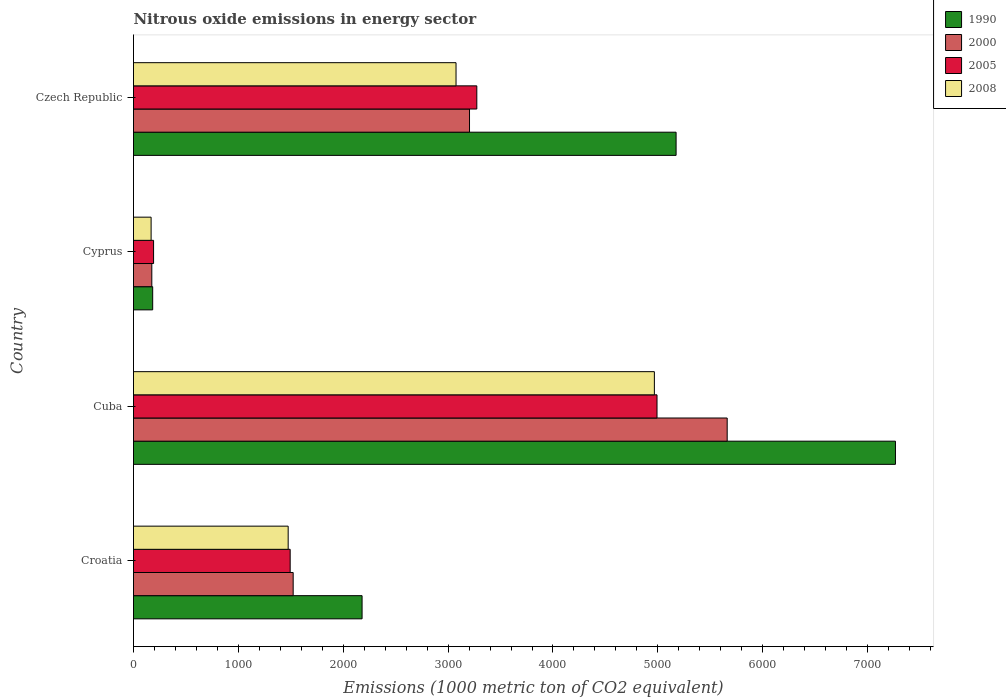How many different coloured bars are there?
Provide a short and direct response. 4. How many bars are there on the 1st tick from the top?
Your answer should be very brief. 4. How many bars are there on the 3rd tick from the bottom?
Provide a short and direct response. 4. What is the label of the 1st group of bars from the top?
Offer a very short reply. Czech Republic. What is the amount of nitrous oxide emitted in 2005 in Croatia?
Provide a short and direct response. 1494. Across all countries, what is the maximum amount of nitrous oxide emitted in 2008?
Ensure brevity in your answer.  4967. Across all countries, what is the minimum amount of nitrous oxide emitted in 2005?
Provide a short and direct response. 191.4. In which country was the amount of nitrous oxide emitted in 2005 maximum?
Offer a very short reply. Cuba. In which country was the amount of nitrous oxide emitted in 2008 minimum?
Keep it short and to the point. Cyprus. What is the total amount of nitrous oxide emitted in 2008 in the graph?
Give a very brief answer. 9685.3. What is the difference between the amount of nitrous oxide emitted in 2008 in Cuba and that in Cyprus?
Your answer should be compact. 4799.1. What is the difference between the amount of nitrous oxide emitted in 2005 in Czech Republic and the amount of nitrous oxide emitted in 2008 in Cuba?
Your answer should be very brief. -1693.3. What is the average amount of nitrous oxide emitted in 1990 per country?
Your response must be concise. 3700.65. What is the difference between the amount of nitrous oxide emitted in 2005 and amount of nitrous oxide emitted in 2000 in Czech Republic?
Your response must be concise. 69.6. In how many countries, is the amount of nitrous oxide emitted in 1990 greater than 1600 1000 metric ton?
Make the answer very short. 3. What is the ratio of the amount of nitrous oxide emitted in 2005 in Croatia to that in Czech Republic?
Provide a succinct answer. 0.46. What is the difference between the highest and the second highest amount of nitrous oxide emitted in 2008?
Provide a short and direct response. 1891.4. What is the difference between the highest and the lowest amount of nitrous oxide emitted in 1990?
Give a very brief answer. 7083. Is the sum of the amount of nitrous oxide emitted in 2008 in Cuba and Cyprus greater than the maximum amount of nitrous oxide emitted in 1990 across all countries?
Your answer should be compact. No. What does the 1st bar from the bottom in Croatia represents?
Your answer should be very brief. 1990. How many countries are there in the graph?
Ensure brevity in your answer.  4. What is the difference between two consecutive major ticks on the X-axis?
Provide a short and direct response. 1000. Are the values on the major ticks of X-axis written in scientific E-notation?
Offer a terse response. No. Does the graph contain grids?
Provide a short and direct response. No. Where does the legend appear in the graph?
Keep it short and to the point. Top right. How are the legend labels stacked?
Your answer should be very brief. Vertical. What is the title of the graph?
Make the answer very short. Nitrous oxide emissions in energy sector. What is the label or title of the X-axis?
Make the answer very short. Emissions (1000 metric ton of CO2 equivalent). What is the label or title of the Y-axis?
Ensure brevity in your answer.  Country. What is the Emissions (1000 metric ton of CO2 equivalent) of 1990 in Croatia?
Your response must be concise. 2179.7. What is the Emissions (1000 metric ton of CO2 equivalent) in 2000 in Croatia?
Give a very brief answer. 1522.5. What is the Emissions (1000 metric ton of CO2 equivalent) of 2005 in Croatia?
Offer a terse response. 1494. What is the Emissions (1000 metric ton of CO2 equivalent) in 2008 in Croatia?
Your response must be concise. 1474.8. What is the Emissions (1000 metric ton of CO2 equivalent) of 1990 in Cuba?
Your answer should be very brief. 7265.9. What is the Emissions (1000 metric ton of CO2 equivalent) in 2000 in Cuba?
Provide a short and direct response. 5661.3. What is the Emissions (1000 metric ton of CO2 equivalent) of 2005 in Cuba?
Your response must be concise. 4992.1. What is the Emissions (1000 metric ton of CO2 equivalent) of 2008 in Cuba?
Offer a very short reply. 4967. What is the Emissions (1000 metric ton of CO2 equivalent) in 1990 in Cyprus?
Keep it short and to the point. 182.9. What is the Emissions (1000 metric ton of CO2 equivalent) in 2000 in Cyprus?
Your answer should be very brief. 174.6. What is the Emissions (1000 metric ton of CO2 equivalent) of 2005 in Cyprus?
Ensure brevity in your answer.  191.4. What is the Emissions (1000 metric ton of CO2 equivalent) of 2008 in Cyprus?
Provide a short and direct response. 167.9. What is the Emissions (1000 metric ton of CO2 equivalent) in 1990 in Czech Republic?
Keep it short and to the point. 5174.1. What is the Emissions (1000 metric ton of CO2 equivalent) in 2000 in Czech Republic?
Keep it short and to the point. 3204.1. What is the Emissions (1000 metric ton of CO2 equivalent) in 2005 in Czech Republic?
Provide a succinct answer. 3273.7. What is the Emissions (1000 metric ton of CO2 equivalent) in 2008 in Czech Republic?
Offer a very short reply. 3075.6. Across all countries, what is the maximum Emissions (1000 metric ton of CO2 equivalent) in 1990?
Your answer should be very brief. 7265.9. Across all countries, what is the maximum Emissions (1000 metric ton of CO2 equivalent) in 2000?
Your response must be concise. 5661.3. Across all countries, what is the maximum Emissions (1000 metric ton of CO2 equivalent) of 2005?
Keep it short and to the point. 4992.1. Across all countries, what is the maximum Emissions (1000 metric ton of CO2 equivalent) in 2008?
Provide a succinct answer. 4967. Across all countries, what is the minimum Emissions (1000 metric ton of CO2 equivalent) in 1990?
Give a very brief answer. 182.9. Across all countries, what is the minimum Emissions (1000 metric ton of CO2 equivalent) in 2000?
Provide a succinct answer. 174.6. Across all countries, what is the minimum Emissions (1000 metric ton of CO2 equivalent) in 2005?
Ensure brevity in your answer.  191.4. Across all countries, what is the minimum Emissions (1000 metric ton of CO2 equivalent) in 2008?
Keep it short and to the point. 167.9. What is the total Emissions (1000 metric ton of CO2 equivalent) in 1990 in the graph?
Offer a terse response. 1.48e+04. What is the total Emissions (1000 metric ton of CO2 equivalent) of 2000 in the graph?
Ensure brevity in your answer.  1.06e+04. What is the total Emissions (1000 metric ton of CO2 equivalent) in 2005 in the graph?
Make the answer very short. 9951.2. What is the total Emissions (1000 metric ton of CO2 equivalent) of 2008 in the graph?
Provide a short and direct response. 9685.3. What is the difference between the Emissions (1000 metric ton of CO2 equivalent) in 1990 in Croatia and that in Cuba?
Keep it short and to the point. -5086.2. What is the difference between the Emissions (1000 metric ton of CO2 equivalent) of 2000 in Croatia and that in Cuba?
Keep it short and to the point. -4138.8. What is the difference between the Emissions (1000 metric ton of CO2 equivalent) in 2005 in Croatia and that in Cuba?
Ensure brevity in your answer.  -3498.1. What is the difference between the Emissions (1000 metric ton of CO2 equivalent) in 2008 in Croatia and that in Cuba?
Your response must be concise. -3492.2. What is the difference between the Emissions (1000 metric ton of CO2 equivalent) in 1990 in Croatia and that in Cyprus?
Offer a very short reply. 1996.8. What is the difference between the Emissions (1000 metric ton of CO2 equivalent) of 2000 in Croatia and that in Cyprus?
Ensure brevity in your answer.  1347.9. What is the difference between the Emissions (1000 metric ton of CO2 equivalent) in 2005 in Croatia and that in Cyprus?
Offer a terse response. 1302.6. What is the difference between the Emissions (1000 metric ton of CO2 equivalent) of 2008 in Croatia and that in Cyprus?
Provide a short and direct response. 1306.9. What is the difference between the Emissions (1000 metric ton of CO2 equivalent) of 1990 in Croatia and that in Czech Republic?
Your response must be concise. -2994.4. What is the difference between the Emissions (1000 metric ton of CO2 equivalent) of 2000 in Croatia and that in Czech Republic?
Ensure brevity in your answer.  -1681.6. What is the difference between the Emissions (1000 metric ton of CO2 equivalent) of 2005 in Croatia and that in Czech Republic?
Your answer should be very brief. -1779.7. What is the difference between the Emissions (1000 metric ton of CO2 equivalent) of 2008 in Croatia and that in Czech Republic?
Ensure brevity in your answer.  -1600.8. What is the difference between the Emissions (1000 metric ton of CO2 equivalent) of 1990 in Cuba and that in Cyprus?
Your response must be concise. 7083. What is the difference between the Emissions (1000 metric ton of CO2 equivalent) of 2000 in Cuba and that in Cyprus?
Make the answer very short. 5486.7. What is the difference between the Emissions (1000 metric ton of CO2 equivalent) in 2005 in Cuba and that in Cyprus?
Your answer should be compact. 4800.7. What is the difference between the Emissions (1000 metric ton of CO2 equivalent) of 2008 in Cuba and that in Cyprus?
Your response must be concise. 4799.1. What is the difference between the Emissions (1000 metric ton of CO2 equivalent) of 1990 in Cuba and that in Czech Republic?
Offer a very short reply. 2091.8. What is the difference between the Emissions (1000 metric ton of CO2 equivalent) in 2000 in Cuba and that in Czech Republic?
Offer a very short reply. 2457.2. What is the difference between the Emissions (1000 metric ton of CO2 equivalent) of 2005 in Cuba and that in Czech Republic?
Offer a terse response. 1718.4. What is the difference between the Emissions (1000 metric ton of CO2 equivalent) in 2008 in Cuba and that in Czech Republic?
Give a very brief answer. 1891.4. What is the difference between the Emissions (1000 metric ton of CO2 equivalent) of 1990 in Cyprus and that in Czech Republic?
Your response must be concise. -4991.2. What is the difference between the Emissions (1000 metric ton of CO2 equivalent) in 2000 in Cyprus and that in Czech Republic?
Make the answer very short. -3029.5. What is the difference between the Emissions (1000 metric ton of CO2 equivalent) in 2005 in Cyprus and that in Czech Republic?
Keep it short and to the point. -3082.3. What is the difference between the Emissions (1000 metric ton of CO2 equivalent) of 2008 in Cyprus and that in Czech Republic?
Your response must be concise. -2907.7. What is the difference between the Emissions (1000 metric ton of CO2 equivalent) of 1990 in Croatia and the Emissions (1000 metric ton of CO2 equivalent) of 2000 in Cuba?
Give a very brief answer. -3481.6. What is the difference between the Emissions (1000 metric ton of CO2 equivalent) in 1990 in Croatia and the Emissions (1000 metric ton of CO2 equivalent) in 2005 in Cuba?
Ensure brevity in your answer.  -2812.4. What is the difference between the Emissions (1000 metric ton of CO2 equivalent) of 1990 in Croatia and the Emissions (1000 metric ton of CO2 equivalent) of 2008 in Cuba?
Your answer should be very brief. -2787.3. What is the difference between the Emissions (1000 metric ton of CO2 equivalent) of 2000 in Croatia and the Emissions (1000 metric ton of CO2 equivalent) of 2005 in Cuba?
Ensure brevity in your answer.  -3469.6. What is the difference between the Emissions (1000 metric ton of CO2 equivalent) in 2000 in Croatia and the Emissions (1000 metric ton of CO2 equivalent) in 2008 in Cuba?
Offer a very short reply. -3444.5. What is the difference between the Emissions (1000 metric ton of CO2 equivalent) of 2005 in Croatia and the Emissions (1000 metric ton of CO2 equivalent) of 2008 in Cuba?
Your answer should be compact. -3473. What is the difference between the Emissions (1000 metric ton of CO2 equivalent) of 1990 in Croatia and the Emissions (1000 metric ton of CO2 equivalent) of 2000 in Cyprus?
Make the answer very short. 2005.1. What is the difference between the Emissions (1000 metric ton of CO2 equivalent) in 1990 in Croatia and the Emissions (1000 metric ton of CO2 equivalent) in 2005 in Cyprus?
Offer a very short reply. 1988.3. What is the difference between the Emissions (1000 metric ton of CO2 equivalent) of 1990 in Croatia and the Emissions (1000 metric ton of CO2 equivalent) of 2008 in Cyprus?
Your answer should be compact. 2011.8. What is the difference between the Emissions (1000 metric ton of CO2 equivalent) in 2000 in Croatia and the Emissions (1000 metric ton of CO2 equivalent) in 2005 in Cyprus?
Your answer should be very brief. 1331.1. What is the difference between the Emissions (1000 metric ton of CO2 equivalent) of 2000 in Croatia and the Emissions (1000 metric ton of CO2 equivalent) of 2008 in Cyprus?
Ensure brevity in your answer.  1354.6. What is the difference between the Emissions (1000 metric ton of CO2 equivalent) of 2005 in Croatia and the Emissions (1000 metric ton of CO2 equivalent) of 2008 in Cyprus?
Ensure brevity in your answer.  1326.1. What is the difference between the Emissions (1000 metric ton of CO2 equivalent) of 1990 in Croatia and the Emissions (1000 metric ton of CO2 equivalent) of 2000 in Czech Republic?
Your response must be concise. -1024.4. What is the difference between the Emissions (1000 metric ton of CO2 equivalent) of 1990 in Croatia and the Emissions (1000 metric ton of CO2 equivalent) of 2005 in Czech Republic?
Offer a terse response. -1094. What is the difference between the Emissions (1000 metric ton of CO2 equivalent) of 1990 in Croatia and the Emissions (1000 metric ton of CO2 equivalent) of 2008 in Czech Republic?
Your answer should be very brief. -895.9. What is the difference between the Emissions (1000 metric ton of CO2 equivalent) of 2000 in Croatia and the Emissions (1000 metric ton of CO2 equivalent) of 2005 in Czech Republic?
Your answer should be very brief. -1751.2. What is the difference between the Emissions (1000 metric ton of CO2 equivalent) of 2000 in Croatia and the Emissions (1000 metric ton of CO2 equivalent) of 2008 in Czech Republic?
Give a very brief answer. -1553.1. What is the difference between the Emissions (1000 metric ton of CO2 equivalent) of 2005 in Croatia and the Emissions (1000 metric ton of CO2 equivalent) of 2008 in Czech Republic?
Keep it short and to the point. -1581.6. What is the difference between the Emissions (1000 metric ton of CO2 equivalent) of 1990 in Cuba and the Emissions (1000 metric ton of CO2 equivalent) of 2000 in Cyprus?
Provide a succinct answer. 7091.3. What is the difference between the Emissions (1000 metric ton of CO2 equivalent) of 1990 in Cuba and the Emissions (1000 metric ton of CO2 equivalent) of 2005 in Cyprus?
Give a very brief answer. 7074.5. What is the difference between the Emissions (1000 metric ton of CO2 equivalent) in 1990 in Cuba and the Emissions (1000 metric ton of CO2 equivalent) in 2008 in Cyprus?
Your response must be concise. 7098. What is the difference between the Emissions (1000 metric ton of CO2 equivalent) of 2000 in Cuba and the Emissions (1000 metric ton of CO2 equivalent) of 2005 in Cyprus?
Offer a terse response. 5469.9. What is the difference between the Emissions (1000 metric ton of CO2 equivalent) of 2000 in Cuba and the Emissions (1000 metric ton of CO2 equivalent) of 2008 in Cyprus?
Keep it short and to the point. 5493.4. What is the difference between the Emissions (1000 metric ton of CO2 equivalent) of 2005 in Cuba and the Emissions (1000 metric ton of CO2 equivalent) of 2008 in Cyprus?
Give a very brief answer. 4824.2. What is the difference between the Emissions (1000 metric ton of CO2 equivalent) in 1990 in Cuba and the Emissions (1000 metric ton of CO2 equivalent) in 2000 in Czech Republic?
Give a very brief answer. 4061.8. What is the difference between the Emissions (1000 metric ton of CO2 equivalent) of 1990 in Cuba and the Emissions (1000 metric ton of CO2 equivalent) of 2005 in Czech Republic?
Give a very brief answer. 3992.2. What is the difference between the Emissions (1000 metric ton of CO2 equivalent) of 1990 in Cuba and the Emissions (1000 metric ton of CO2 equivalent) of 2008 in Czech Republic?
Provide a short and direct response. 4190.3. What is the difference between the Emissions (1000 metric ton of CO2 equivalent) of 2000 in Cuba and the Emissions (1000 metric ton of CO2 equivalent) of 2005 in Czech Republic?
Provide a succinct answer. 2387.6. What is the difference between the Emissions (1000 metric ton of CO2 equivalent) in 2000 in Cuba and the Emissions (1000 metric ton of CO2 equivalent) in 2008 in Czech Republic?
Your answer should be very brief. 2585.7. What is the difference between the Emissions (1000 metric ton of CO2 equivalent) in 2005 in Cuba and the Emissions (1000 metric ton of CO2 equivalent) in 2008 in Czech Republic?
Your answer should be very brief. 1916.5. What is the difference between the Emissions (1000 metric ton of CO2 equivalent) in 1990 in Cyprus and the Emissions (1000 metric ton of CO2 equivalent) in 2000 in Czech Republic?
Provide a succinct answer. -3021.2. What is the difference between the Emissions (1000 metric ton of CO2 equivalent) in 1990 in Cyprus and the Emissions (1000 metric ton of CO2 equivalent) in 2005 in Czech Republic?
Your answer should be compact. -3090.8. What is the difference between the Emissions (1000 metric ton of CO2 equivalent) in 1990 in Cyprus and the Emissions (1000 metric ton of CO2 equivalent) in 2008 in Czech Republic?
Offer a terse response. -2892.7. What is the difference between the Emissions (1000 metric ton of CO2 equivalent) in 2000 in Cyprus and the Emissions (1000 metric ton of CO2 equivalent) in 2005 in Czech Republic?
Offer a terse response. -3099.1. What is the difference between the Emissions (1000 metric ton of CO2 equivalent) of 2000 in Cyprus and the Emissions (1000 metric ton of CO2 equivalent) of 2008 in Czech Republic?
Your answer should be compact. -2901. What is the difference between the Emissions (1000 metric ton of CO2 equivalent) in 2005 in Cyprus and the Emissions (1000 metric ton of CO2 equivalent) in 2008 in Czech Republic?
Ensure brevity in your answer.  -2884.2. What is the average Emissions (1000 metric ton of CO2 equivalent) of 1990 per country?
Your answer should be very brief. 3700.65. What is the average Emissions (1000 metric ton of CO2 equivalent) in 2000 per country?
Keep it short and to the point. 2640.62. What is the average Emissions (1000 metric ton of CO2 equivalent) in 2005 per country?
Ensure brevity in your answer.  2487.8. What is the average Emissions (1000 metric ton of CO2 equivalent) of 2008 per country?
Your answer should be compact. 2421.32. What is the difference between the Emissions (1000 metric ton of CO2 equivalent) in 1990 and Emissions (1000 metric ton of CO2 equivalent) in 2000 in Croatia?
Provide a short and direct response. 657.2. What is the difference between the Emissions (1000 metric ton of CO2 equivalent) in 1990 and Emissions (1000 metric ton of CO2 equivalent) in 2005 in Croatia?
Your answer should be compact. 685.7. What is the difference between the Emissions (1000 metric ton of CO2 equivalent) in 1990 and Emissions (1000 metric ton of CO2 equivalent) in 2008 in Croatia?
Offer a terse response. 704.9. What is the difference between the Emissions (1000 metric ton of CO2 equivalent) of 2000 and Emissions (1000 metric ton of CO2 equivalent) of 2008 in Croatia?
Make the answer very short. 47.7. What is the difference between the Emissions (1000 metric ton of CO2 equivalent) in 2005 and Emissions (1000 metric ton of CO2 equivalent) in 2008 in Croatia?
Provide a short and direct response. 19.2. What is the difference between the Emissions (1000 metric ton of CO2 equivalent) in 1990 and Emissions (1000 metric ton of CO2 equivalent) in 2000 in Cuba?
Offer a very short reply. 1604.6. What is the difference between the Emissions (1000 metric ton of CO2 equivalent) in 1990 and Emissions (1000 metric ton of CO2 equivalent) in 2005 in Cuba?
Offer a terse response. 2273.8. What is the difference between the Emissions (1000 metric ton of CO2 equivalent) of 1990 and Emissions (1000 metric ton of CO2 equivalent) of 2008 in Cuba?
Provide a short and direct response. 2298.9. What is the difference between the Emissions (1000 metric ton of CO2 equivalent) in 2000 and Emissions (1000 metric ton of CO2 equivalent) in 2005 in Cuba?
Make the answer very short. 669.2. What is the difference between the Emissions (1000 metric ton of CO2 equivalent) in 2000 and Emissions (1000 metric ton of CO2 equivalent) in 2008 in Cuba?
Offer a terse response. 694.3. What is the difference between the Emissions (1000 metric ton of CO2 equivalent) of 2005 and Emissions (1000 metric ton of CO2 equivalent) of 2008 in Cuba?
Make the answer very short. 25.1. What is the difference between the Emissions (1000 metric ton of CO2 equivalent) in 1990 and Emissions (1000 metric ton of CO2 equivalent) in 2000 in Cyprus?
Keep it short and to the point. 8.3. What is the difference between the Emissions (1000 metric ton of CO2 equivalent) of 2000 and Emissions (1000 metric ton of CO2 equivalent) of 2005 in Cyprus?
Provide a short and direct response. -16.8. What is the difference between the Emissions (1000 metric ton of CO2 equivalent) in 2005 and Emissions (1000 metric ton of CO2 equivalent) in 2008 in Cyprus?
Offer a terse response. 23.5. What is the difference between the Emissions (1000 metric ton of CO2 equivalent) of 1990 and Emissions (1000 metric ton of CO2 equivalent) of 2000 in Czech Republic?
Provide a succinct answer. 1970. What is the difference between the Emissions (1000 metric ton of CO2 equivalent) in 1990 and Emissions (1000 metric ton of CO2 equivalent) in 2005 in Czech Republic?
Give a very brief answer. 1900.4. What is the difference between the Emissions (1000 metric ton of CO2 equivalent) in 1990 and Emissions (1000 metric ton of CO2 equivalent) in 2008 in Czech Republic?
Ensure brevity in your answer.  2098.5. What is the difference between the Emissions (1000 metric ton of CO2 equivalent) in 2000 and Emissions (1000 metric ton of CO2 equivalent) in 2005 in Czech Republic?
Offer a very short reply. -69.6. What is the difference between the Emissions (1000 metric ton of CO2 equivalent) of 2000 and Emissions (1000 metric ton of CO2 equivalent) of 2008 in Czech Republic?
Ensure brevity in your answer.  128.5. What is the difference between the Emissions (1000 metric ton of CO2 equivalent) of 2005 and Emissions (1000 metric ton of CO2 equivalent) of 2008 in Czech Republic?
Your response must be concise. 198.1. What is the ratio of the Emissions (1000 metric ton of CO2 equivalent) in 1990 in Croatia to that in Cuba?
Provide a short and direct response. 0.3. What is the ratio of the Emissions (1000 metric ton of CO2 equivalent) of 2000 in Croatia to that in Cuba?
Offer a very short reply. 0.27. What is the ratio of the Emissions (1000 metric ton of CO2 equivalent) of 2005 in Croatia to that in Cuba?
Ensure brevity in your answer.  0.3. What is the ratio of the Emissions (1000 metric ton of CO2 equivalent) in 2008 in Croatia to that in Cuba?
Give a very brief answer. 0.3. What is the ratio of the Emissions (1000 metric ton of CO2 equivalent) of 1990 in Croatia to that in Cyprus?
Offer a very short reply. 11.92. What is the ratio of the Emissions (1000 metric ton of CO2 equivalent) in 2000 in Croatia to that in Cyprus?
Make the answer very short. 8.72. What is the ratio of the Emissions (1000 metric ton of CO2 equivalent) in 2005 in Croatia to that in Cyprus?
Give a very brief answer. 7.81. What is the ratio of the Emissions (1000 metric ton of CO2 equivalent) of 2008 in Croatia to that in Cyprus?
Your answer should be very brief. 8.78. What is the ratio of the Emissions (1000 metric ton of CO2 equivalent) in 1990 in Croatia to that in Czech Republic?
Your response must be concise. 0.42. What is the ratio of the Emissions (1000 metric ton of CO2 equivalent) in 2000 in Croatia to that in Czech Republic?
Keep it short and to the point. 0.48. What is the ratio of the Emissions (1000 metric ton of CO2 equivalent) of 2005 in Croatia to that in Czech Republic?
Make the answer very short. 0.46. What is the ratio of the Emissions (1000 metric ton of CO2 equivalent) of 2008 in Croatia to that in Czech Republic?
Your answer should be very brief. 0.48. What is the ratio of the Emissions (1000 metric ton of CO2 equivalent) of 1990 in Cuba to that in Cyprus?
Provide a short and direct response. 39.73. What is the ratio of the Emissions (1000 metric ton of CO2 equivalent) in 2000 in Cuba to that in Cyprus?
Give a very brief answer. 32.42. What is the ratio of the Emissions (1000 metric ton of CO2 equivalent) of 2005 in Cuba to that in Cyprus?
Make the answer very short. 26.08. What is the ratio of the Emissions (1000 metric ton of CO2 equivalent) of 2008 in Cuba to that in Cyprus?
Ensure brevity in your answer.  29.58. What is the ratio of the Emissions (1000 metric ton of CO2 equivalent) in 1990 in Cuba to that in Czech Republic?
Make the answer very short. 1.4. What is the ratio of the Emissions (1000 metric ton of CO2 equivalent) of 2000 in Cuba to that in Czech Republic?
Your answer should be compact. 1.77. What is the ratio of the Emissions (1000 metric ton of CO2 equivalent) of 2005 in Cuba to that in Czech Republic?
Your response must be concise. 1.52. What is the ratio of the Emissions (1000 metric ton of CO2 equivalent) of 2008 in Cuba to that in Czech Republic?
Your answer should be compact. 1.61. What is the ratio of the Emissions (1000 metric ton of CO2 equivalent) of 1990 in Cyprus to that in Czech Republic?
Keep it short and to the point. 0.04. What is the ratio of the Emissions (1000 metric ton of CO2 equivalent) of 2000 in Cyprus to that in Czech Republic?
Your answer should be compact. 0.05. What is the ratio of the Emissions (1000 metric ton of CO2 equivalent) in 2005 in Cyprus to that in Czech Republic?
Offer a very short reply. 0.06. What is the ratio of the Emissions (1000 metric ton of CO2 equivalent) of 2008 in Cyprus to that in Czech Republic?
Your answer should be compact. 0.05. What is the difference between the highest and the second highest Emissions (1000 metric ton of CO2 equivalent) of 1990?
Make the answer very short. 2091.8. What is the difference between the highest and the second highest Emissions (1000 metric ton of CO2 equivalent) in 2000?
Ensure brevity in your answer.  2457.2. What is the difference between the highest and the second highest Emissions (1000 metric ton of CO2 equivalent) in 2005?
Offer a very short reply. 1718.4. What is the difference between the highest and the second highest Emissions (1000 metric ton of CO2 equivalent) in 2008?
Offer a very short reply. 1891.4. What is the difference between the highest and the lowest Emissions (1000 metric ton of CO2 equivalent) in 1990?
Make the answer very short. 7083. What is the difference between the highest and the lowest Emissions (1000 metric ton of CO2 equivalent) of 2000?
Your answer should be compact. 5486.7. What is the difference between the highest and the lowest Emissions (1000 metric ton of CO2 equivalent) in 2005?
Provide a succinct answer. 4800.7. What is the difference between the highest and the lowest Emissions (1000 metric ton of CO2 equivalent) of 2008?
Provide a short and direct response. 4799.1. 